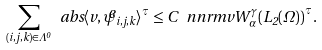<formula> <loc_0><loc_0><loc_500><loc_500>\sum _ { ( i , j , k ) \in \Lambda ^ { 0 } } \ a b s { \langle v , \widetilde { \psi } _ { i , j , k } \rangle } ^ { \tau } \leq C \, \ n n r m { v } { W ^ { \gamma } _ { \alpha } ( L _ { 2 } ( \Omega ) ) } ^ { \tau } .</formula> 